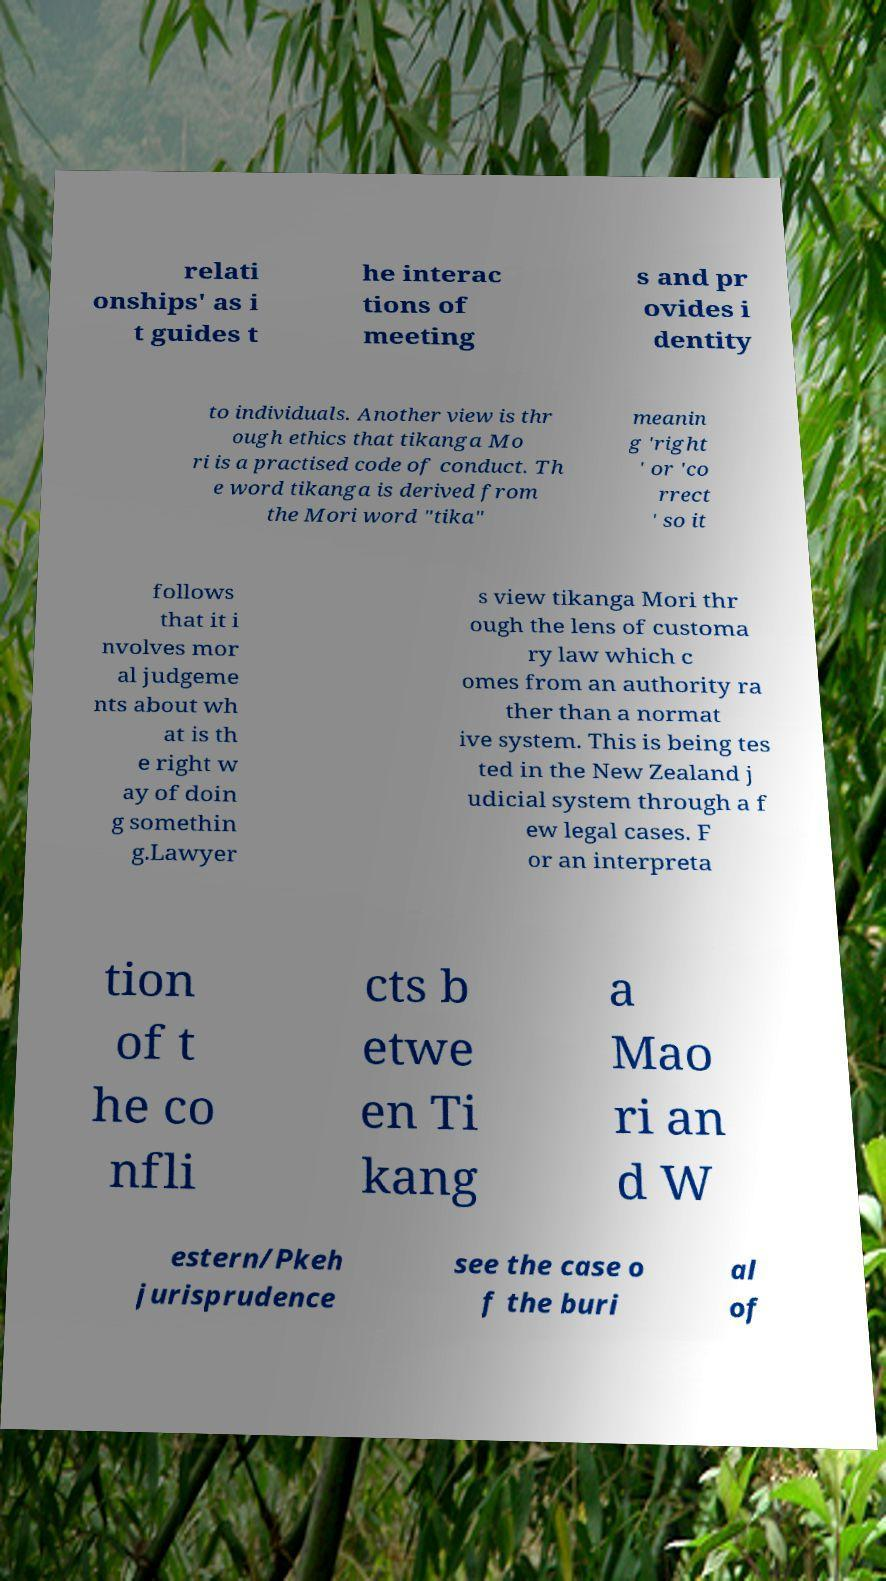Please read and relay the text visible in this image. What does it say? relati onships' as i t guides t he interac tions of meeting s and pr ovides i dentity to individuals. Another view is thr ough ethics that tikanga Mo ri is a practised code of conduct. Th e word tikanga is derived from the Mori word "tika" meanin g 'right ' or 'co rrect ' so it follows that it i nvolves mor al judgeme nts about wh at is th e right w ay of doin g somethin g.Lawyer s view tikanga Mori thr ough the lens of customa ry law which c omes from an authority ra ther than a normat ive system. This is being tes ted in the New Zealand j udicial system through a f ew legal cases. F or an interpreta tion of t he co nfli cts b etwe en Ti kang a Mao ri an d W estern/Pkeh jurisprudence see the case o f the buri al of 